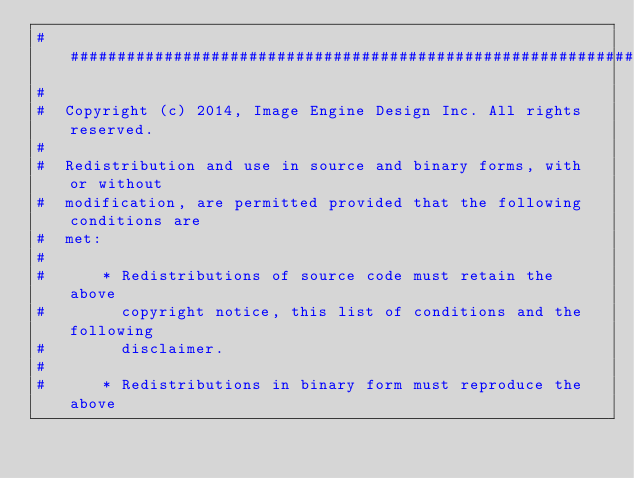Convert code to text. <code><loc_0><loc_0><loc_500><loc_500><_Python_>##########################################################################
#
#  Copyright (c) 2014, Image Engine Design Inc. All rights reserved.
#
#  Redistribution and use in source and binary forms, with or without
#  modification, are permitted provided that the following conditions are
#  met:
#
#      * Redistributions of source code must retain the above
#        copyright notice, this list of conditions and the following
#        disclaimer.
#
#      * Redistributions in binary form must reproduce the above</code> 